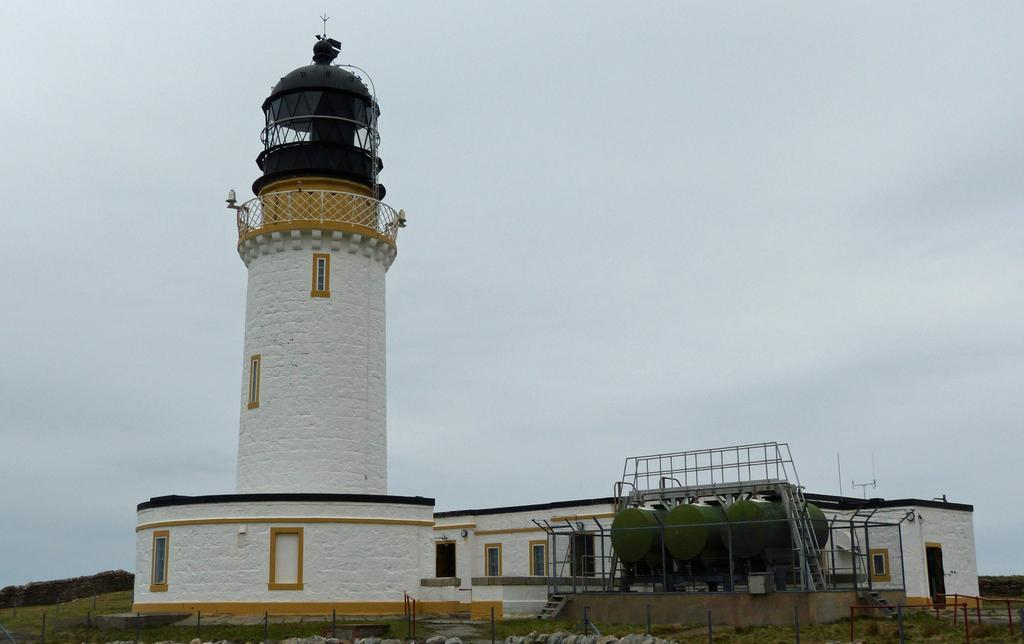What is the main structure in the image? There is a tower in the image. What other type of structure is present in the image? There is a building in the image. What feature of the building can be seen in the image? The building has windows. What type of barrier is visible in the image? There is a fence in the image. What type of storage containers are present in the image? There are storage tanks in the image. What type of long, thin objects are visible in the image? There are rods in the image. What type of safety feature is present in the image? There is a railing in the image. What type of vegetation is present in the image? There is grass in the image. What can be seen in the background of the image? The sky is visible in the background of the image. What type of toys are scattered on the grass in the image? There are no toys present in the image; it features a tower, a building, a fence, storage tanks, rods, a railing, grass, and a sky in the background. 